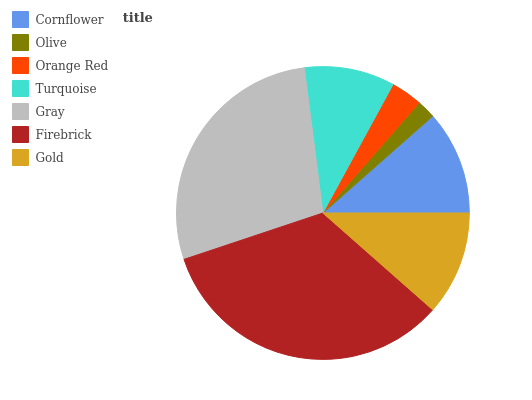Is Olive the minimum?
Answer yes or no. Yes. Is Firebrick the maximum?
Answer yes or no. Yes. Is Orange Red the minimum?
Answer yes or no. No. Is Orange Red the maximum?
Answer yes or no. No. Is Orange Red greater than Olive?
Answer yes or no. Yes. Is Olive less than Orange Red?
Answer yes or no. Yes. Is Olive greater than Orange Red?
Answer yes or no. No. Is Orange Red less than Olive?
Answer yes or no. No. Is Gold the high median?
Answer yes or no. Yes. Is Gold the low median?
Answer yes or no. Yes. Is Gray the high median?
Answer yes or no. No. Is Firebrick the low median?
Answer yes or no. No. 